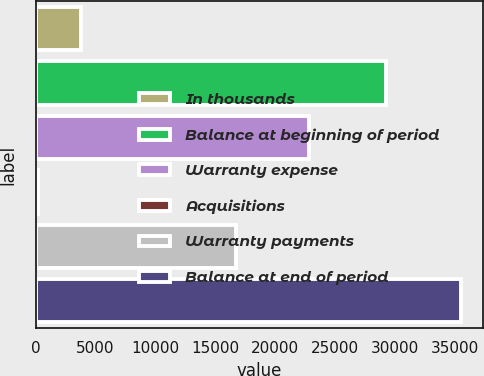Convert chart. <chart><loc_0><loc_0><loc_500><loc_500><bar_chart><fcel>In thousands<fcel>Balance at beginning of period<fcel>Warranty expense<fcel>Acquisitions<fcel>Warranty payments<fcel>Balance at end of period<nl><fcel>3744.8<fcel>29207<fcel>22841<fcel>215<fcel>16750<fcel>35513<nl></chart> 